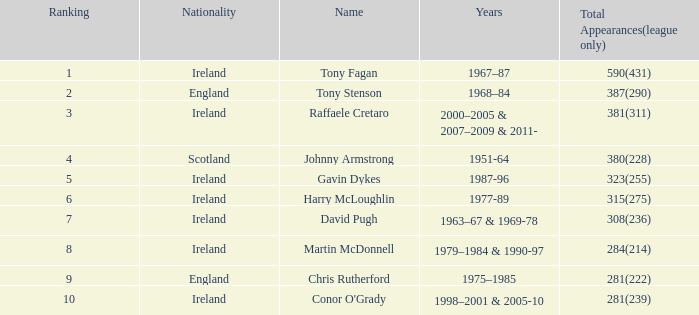What nationality has a ranking less than 7 with tony stenson as the name? England. 